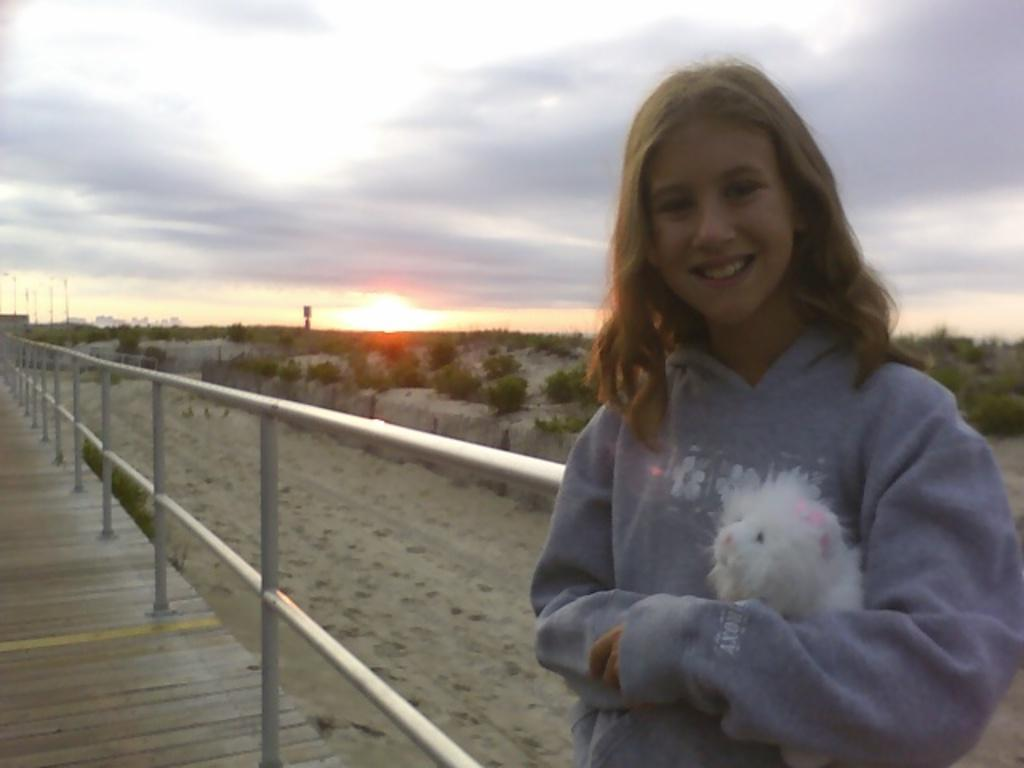Who is present in the image? There is a girl in the image. What is the girl doing in the image? The girl is smiling in the image. What is the girl holding in the image? The girl is holding an object in the image. What can be seen behind the girl in the image? There is a railing behind the girl in the image. What is visible in the background of the image? Trees and the sky are visible in the background of the image. What type of cork can be seen floating in the water in the image? There is no water or cork present in the image; it features a girl smiling and holding an object with a railing and trees in the background. 